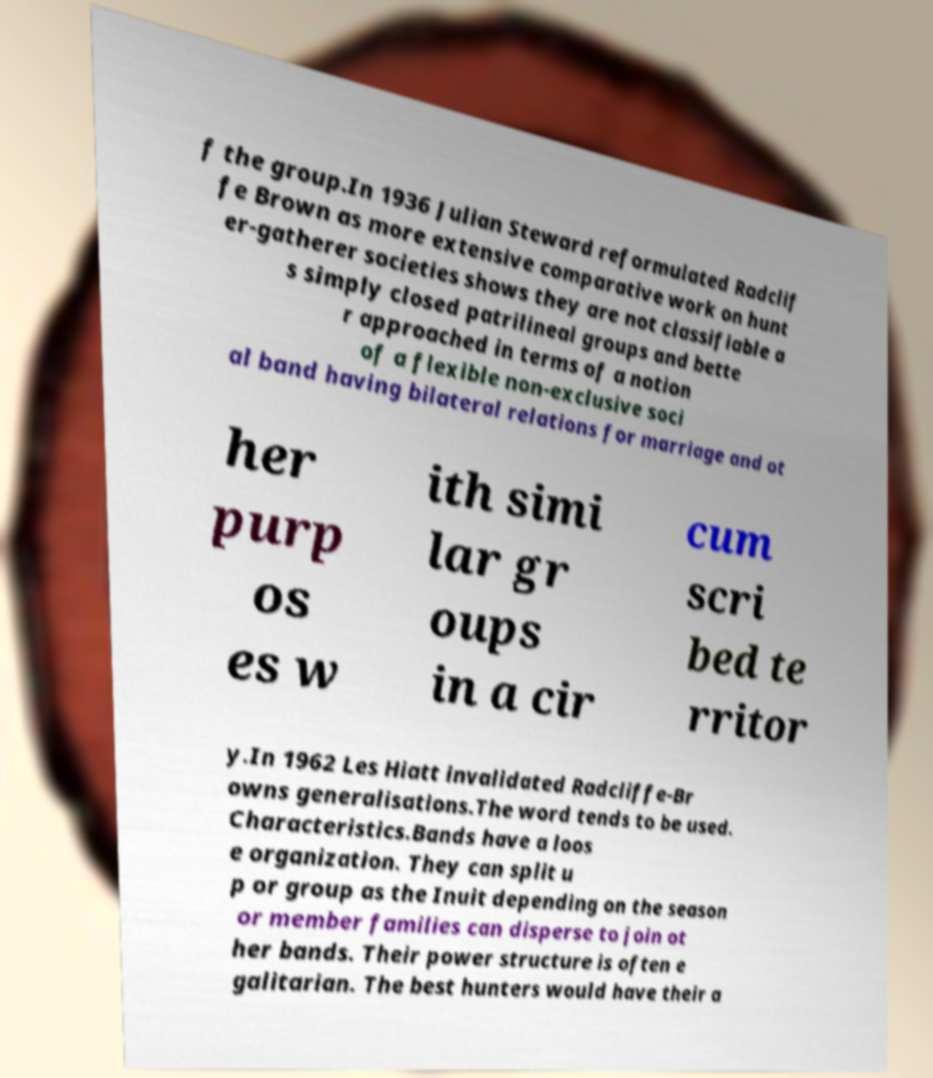Could you assist in decoding the text presented in this image and type it out clearly? f the group.In 1936 Julian Steward reformulated Radclif fe Brown as more extensive comparative work on hunt er-gatherer societies shows they are not classifiable a s simply closed patrilineal groups and bette r approached in terms of a notion of a flexible non-exclusive soci al band having bilateral relations for marriage and ot her purp os es w ith simi lar gr oups in a cir cum scri bed te rritor y.In 1962 Les Hiatt invalidated Radcliffe-Br owns generalisations.The word tends to be used. Characteristics.Bands have a loos e organization. They can split u p or group as the Inuit depending on the season or member families can disperse to join ot her bands. Their power structure is often e galitarian. The best hunters would have their a 